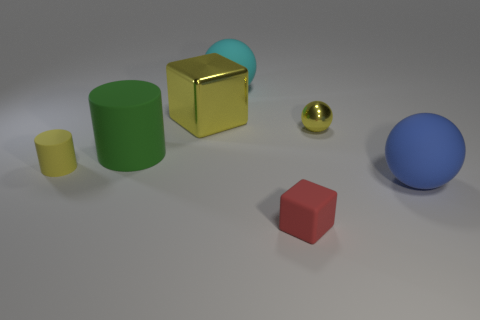Are there more green matte cylinders than yellow objects?
Make the answer very short. No. What is the big yellow block made of?
Ensure brevity in your answer.  Metal. How many big yellow objects are on the right side of the tiny yellow metallic thing that is on the right side of the large yellow cube?
Offer a terse response. 0. There is a small ball; is it the same color as the cube that is right of the large cyan matte sphere?
Offer a terse response. No. There is a matte cylinder that is the same size as the shiny block; what color is it?
Provide a succinct answer. Green. Are there any big brown things of the same shape as the big green rubber thing?
Offer a very short reply. No. Are there fewer large gray matte balls than objects?
Offer a terse response. Yes. The big matte object that is behind the large green object is what color?
Your response must be concise. Cyan. There is a tiny matte object to the right of the large rubber object that is behind the tiny metallic thing; what shape is it?
Your answer should be compact. Cube. Are the small red thing and the ball in front of the big green rubber object made of the same material?
Offer a terse response. Yes. 